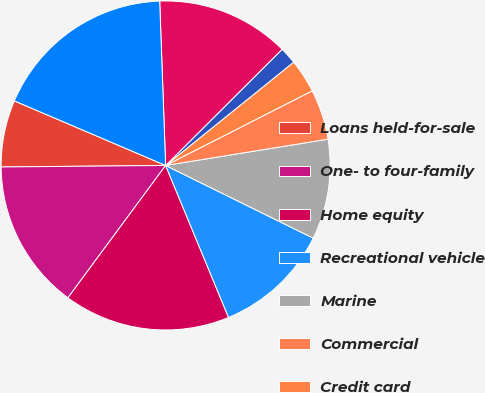<chart> <loc_0><loc_0><loc_500><loc_500><pie_chart><fcel>Loans held-for-sale<fcel>One- to four-family<fcel>Home equity<fcel>Recreational vehicle<fcel>Marine<fcel>Commercial<fcel>Credit card<fcel>Other<fcel>Total consumer and other loans<fcel>Total loans receivable<nl><fcel>6.57%<fcel>14.73%<fcel>16.37%<fcel>11.47%<fcel>9.84%<fcel>4.94%<fcel>3.31%<fcel>1.67%<fcel>13.1%<fcel>18.0%<nl></chart> 